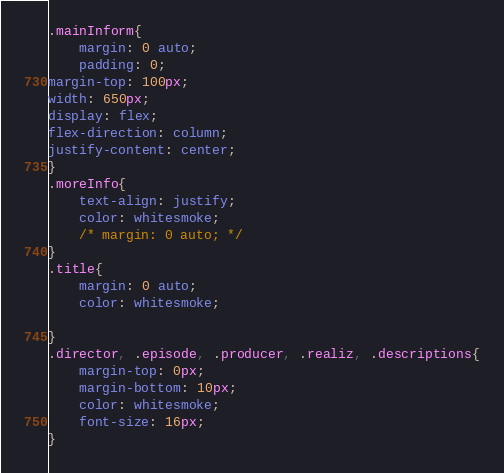<code> <loc_0><loc_0><loc_500><loc_500><_CSS_>.mainInform{
    margin: 0 auto;
    padding: 0;
margin-top: 100px;
width: 650px;
display: flex;
flex-direction: column;
justify-content: center;
}
.moreInfo{
    text-align: justify;
    color: whitesmoke;
    /* margin: 0 auto; */
}
.title{
    margin: 0 auto;
    color: whitesmoke;

}
.director, .episode, .producer, .realiz, .descriptions{
    margin-top: 0px;
    margin-bottom: 10px;
    color: whitesmoke;
    font-size: 16px;
}</code> 